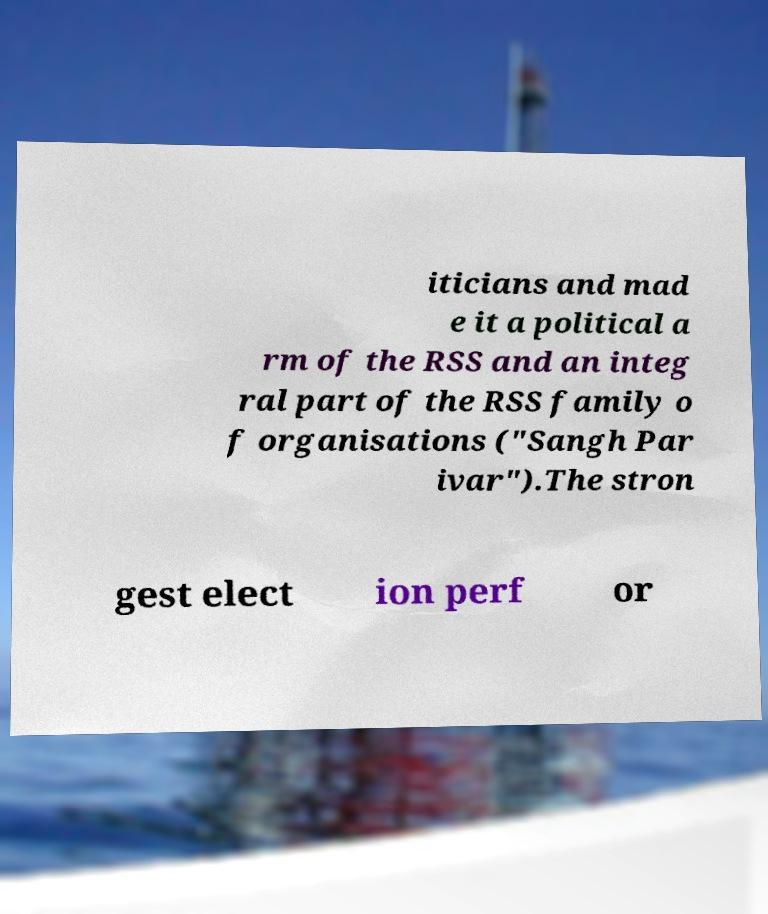I need the written content from this picture converted into text. Can you do that? iticians and mad e it a political a rm of the RSS and an integ ral part of the RSS family o f organisations ("Sangh Par ivar").The stron gest elect ion perf or 